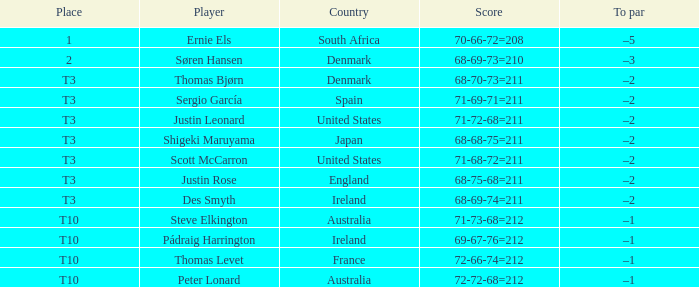What was the place when the score was 68-75-68=211? T3. 